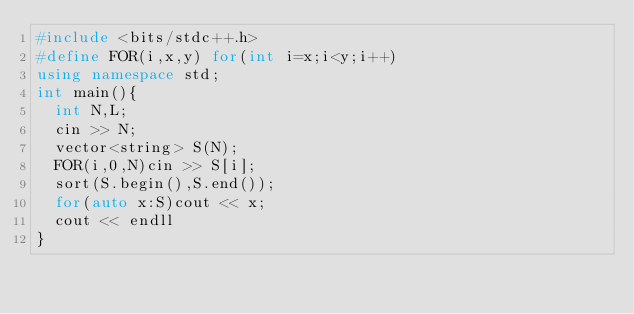Convert code to text. <code><loc_0><loc_0><loc_500><loc_500><_C++_>#include <bits/stdc++.h>
#define FOR(i,x,y) for(int i=x;i<y;i++)
using namespace std;
int main(){
  int N,L;
  cin >> N;
  vector<string> S(N);
  FOR(i,0,N)cin >> S[i];
  sort(S.begin(),S.end());
  for(auto x:S)cout << x;
  cout << endll
}
</code> 